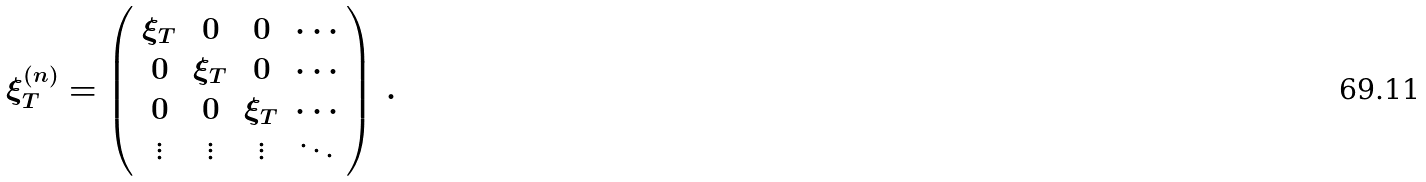Convert formula to latex. <formula><loc_0><loc_0><loc_500><loc_500>\xi _ { T } ^ { ( n ) } = \left ( \begin{array} { c c c c } \xi _ { T } & 0 & 0 & \cdots \\ 0 & \xi _ { T } & 0 & \cdots \\ 0 & 0 & \xi _ { T } & \cdots \\ \vdots & \vdots & \vdots & \ddots \end{array} \right ) \, .</formula> 